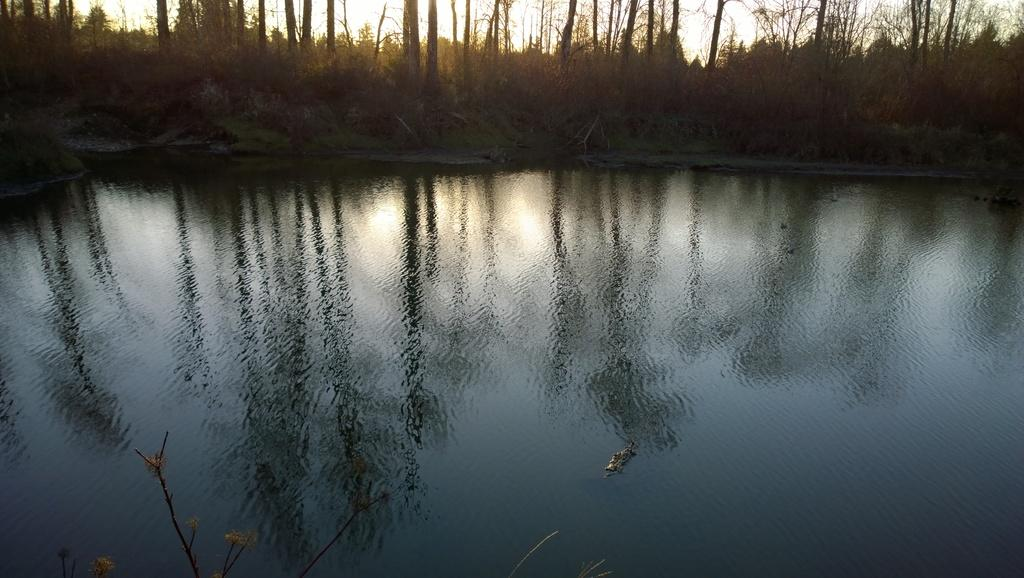What body of water is present in the image? There is a lake in the image. What can be seen in the lake's reflection? The lake has a reflection of trees. What type of vegetation is visible near the lake? There are trees visible near the lake. What type of music can be heard coming from the lake in the image? There is no music present in the image; it is a still image of a lake with a reflection of trees and nearby trees. 